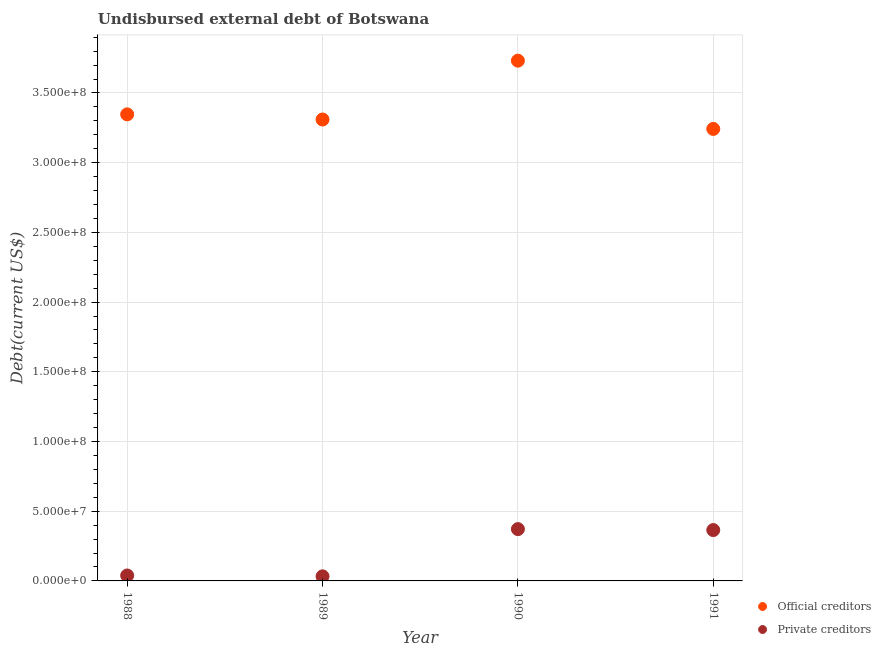What is the undisbursed external debt of private creditors in 1988?
Keep it short and to the point. 3.90e+06. Across all years, what is the maximum undisbursed external debt of official creditors?
Your answer should be very brief. 3.73e+08. Across all years, what is the minimum undisbursed external debt of official creditors?
Your answer should be very brief. 3.24e+08. In which year was the undisbursed external debt of private creditors maximum?
Offer a terse response. 1990. What is the total undisbursed external debt of private creditors in the graph?
Give a very brief answer. 8.08e+07. What is the difference between the undisbursed external debt of private creditors in 1988 and that in 1990?
Offer a very short reply. -3.33e+07. What is the difference between the undisbursed external debt of private creditors in 1989 and the undisbursed external debt of official creditors in 1988?
Your response must be concise. -3.31e+08. What is the average undisbursed external debt of private creditors per year?
Offer a very short reply. 2.02e+07. In the year 1990, what is the difference between the undisbursed external debt of official creditors and undisbursed external debt of private creditors?
Make the answer very short. 3.36e+08. What is the ratio of the undisbursed external debt of official creditors in 1990 to that in 1991?
Offer a terse response. 1.15. Is the difference between the undisbursed external debt of private creditors in 1988 and 1990 greater than the difference between the undisbursed external debt of official creditors in 1988 and 1990?
Give a very brief answer. Yes. What is the difference between the highest and the second highest undisbursed external debt of official creditors?
Your answer should be very brief. 3.85e+07. What is the difference between the highest and the lowest undisbursed external debt of official creditors?
Ensure brevity in your answer.  4.90e+07. Is the sum of the undisbursed external debt of official creditors in 1988 and 1991 greater than the maximum undisbursed external debt of private creditors across all years?
Provide a succinct answer. Yes. Does the undisbursed external debt of official creditors monotonically increase over the years?
Keep it short and to the point. No. Is the undisbursed external debt of official creditors strictly less than the undisbursed external debt of private creditors over the years?
Your answer should be very brief. No. What is the difference between two consecutive major ticks on the Y-axis?
Your answer should be very brief. 5.00e+07. Are the values on the major ticks of Y-axis written in scientific E-notation?
Your answer should be compact. Yes. Does the graph contain any zero values?
Ensure brevity in your answer.  No. Does the graph contain grids?
Provide a short and direct response. Yes. Where does the legend appear in the graph?
Provide a succinct answer. Bottom right. How many legend labels are there?
Your answer should be very brief. 2. What is the title of the graph?
Your answer should be very brief. Undisbursed external debt of Botswana. Does "From production" appear as one of the legend labels in the graph?
Provide a succinct answer. No. What is the label or title of the Y-axis?
Offer a terse response. Debt(current US$). What is the Debt(current US$) of Official creditors in 1988?
Provide a succinct answer. 3.35e+08. What is the Debt(current US$) in Private creditors in 1988?
Offer a very short reply. 3.90e+06. What is the Debt(current US$) in Official creditors in 1989?
Ensure brevity in your answer.  3.31e+08. What is the Debt(current US$) in Private creditors in 1989?
Your answer should be compact. 3.28e+06. What is the Debt(current US$) of Official creditors in 1990?
Your answer should be very brief. 3.73e+08. What is the Debt(current US$) in Private creditors in 1990?
Make the answer very short. 3.72e+07. What is the Debt(current US$) of Official creditors in 1991?
Your answer should be compact. 3.24e+08. What is the Debt(current US$) of Private creditors in 1991?
Your answer should be very brief. 3.65e+07. Across all years, what is the maximum Debt(current US$) in Official creditors?
Provide a succinct answer. 3.73e+08. Across all years, what is the maximum Debt(current US$) in Private creditors?
Provide a short and direct response. 3.72e+07. Across all years, what is the minimum Debt(current US$) in Official creditors?
Give a very brief answer. 3.24e+08. Across all years, what is the minimum Debt(current US$) in Private creditors?
Ensure brevity in your answer.  3.28e+06. What is the total Debt(current US$) in Official creditors in the graph?
Your answer should be compact. 1.36e+09. What is the total Debt(current US$) in Private creditors in the graph?
Your response must be concise. 8.08e+07. What is the difference between the Debt(current US$) in Official creditors in 1988 and that in 1989?
Provide a succinct answer. 3.68e+06. What is the difference between the Debt(current US$) of Private creditors in 1988 and that in 1989?
Make the answer very short. 6.15e+05. What is the difference between the Debt(current US$) in Official creditors in 1988 and that in 1990?
Offer a terse response. -3.85e+07. What is the difference between the Debt(current US$) of Private creditors in 1988 and that in 1990?
Give a very brief answer. -3.33e+07. What is the difference between the Debt(current US$) of Official creditors in 1988 and that in 1991?
Your answer should be very brief. 1.04e+07. What is the difference between the Debt(current US$) of Private creditors in 1988 and that in 1991?
Make the answer very short. -3.26e+07. What is the difference between the Debt(current US$) of Official creditors in 1989 and that in 1990?
Offer a very short reply. -4.22e+07. What is the difference between the Debt(current US$) of Private creditors in 1989 and that in 1990?
Make the answer very short. -3.39e+07. What is the difference between the Debt(current US$) of Official creditors in 1989 and that in 1991?
Offer a terse response. 6.74e+06. What is the difference between the Debt(current US$) in Private creditors in 1989 and that in 1991?
Offer a very short reply. -3.32e+07. What is the difference between the Debt(current US$) in Official creditors in 1990 and that in 1991?
Give a very brief answer. 4.90e+07. What is the difference between the Debt(current US$) in Private creditors in 1990 and that in 1991?
Give a very brief answer. 6.88e+05. What is the difference between the Debt(current US$) in Official creditors in 1988 and the Debt(current US$) in Private creditors in 1989?
Keep it short and to the point. 3.31e+08. What is the difference between the Debt(current US$) in Official creditors in 1988 and the Debt(current US$) in Private creditors in 1990?
Keep it short and to the point. 2.97e+08. What is the difference between the Debt(current US$) of Official creditors in 1988 and the Debt(current US$) of Private creditors in 1991?
Offer a terse response. 2.98e+08. What is the difference between the Debt(current US$) of Official creditors in 1989 and the Debt(current US$) of Private creditors in 1990?
Your answer should be very brief. 2.94e+08. What is the difference between the Debt(current US$) of Official creditors in 1989 and the Debt(current US$) of Private creditors in 1991?
Make the answer very short. 2.94e+08. What is the difference between the Debt(current US$) of Official creditors in 1990 and the Debt(current US$) of Private creditors in 1991?
Offer a terse response. 3.37e+08. What is the average Debt(current US$) of Official creditors per year?
Offer a very short reply. 3.41e+08. What is the average Debt(current US$) in Private creditors per year?
Make the answer very short. 2.02e+07. In the year 1988, what is the difference between the Debt(current US$) of Official creditors and Debt(current US$) of Private creditors?
Offer a very short reply. 3.31e+08. In the year 1989, what is the difference between the Debt(current US$) in Official creditors and Debt(current US$) in Private creditors?
Your response must be concise. 3.28e+08. In the year 1990, what is the difference between the Debt(current US$) in Official creditors and Debt(current US$) in Private creditors?
Make the answer very short. 3.36e+08. In the year 1991, what is the difference between the Debt(current US$) of Official creditors and Debt(current US$) of Private creditors?
Provide a short and direct response. 2.88e+08. What is the ratio of the Debt(current US$) of Official creditors in 1988 to that in 1989?
Provide a succinct answer. 1.01. What is the ratio of the Debt(current US$) of Private creditors in 1988 to that in 1989?
Your answer should be compact. 1.19. What is the ratio of the Debt(current US$) of Official creditors in 1988 to that in 1990?
Give a very brief answer. 0.9. What is the ratio of the Debt(current US$) of Private creditors in 1988 to that in 1990?
Offer a very short reply. 0.1. What is the ratio of the Debt(current US$) in Official creditors in 1988 to that in 1991?
Give a very brief answer. 1.03. What is the ratio of the Debt(current US$) in Private creditors in 1988 to that in 1991?
Your answer should be compact. 0.11. What is the ratio of the Debt(current US$) in Official creditors in 1989 to that in 1990?
Offer a terse response. 0.89. What is the ratio of the Debt(current US$) of Private creditors in 1989 to that in 1990?
Give a very brief answer. 0.09. What is the ratio of the Debt(current US$) in Official creditors in 1989 to that in 1991?
Make the answer very short. 1.02. What is the ratio of the Debt(current US$) of Private creditors in 1989 to that in 1991?
Keep it short and to the point. 0.09. What is the ratio of the Debt(current US$) in Official creditors in 1990 to that in 1991?
Give a very brief answer. 1.15. What is the ratio of the Debt(current US$) of Private creditors in 1990 to that in 1991?
Offer a terse response. 1.02. What is the difference between the highest and the second highest Debt(current US$) of Official creditors?
Your response must be concise. 3.85e+07. What is the difference between the highest and the second highest Debt(current US$) in Private creditors?
Ensure brevity in your answer.  6.88e+05. What is the difference between the highest and the lowest Debt(current US$) in Official creditors?
Offer a terse response. 4.90e+07. What is the difference between the highest and the lowest Debt(current US$) of Private creditors?
Offer a very short reply. 3.39e+07. 